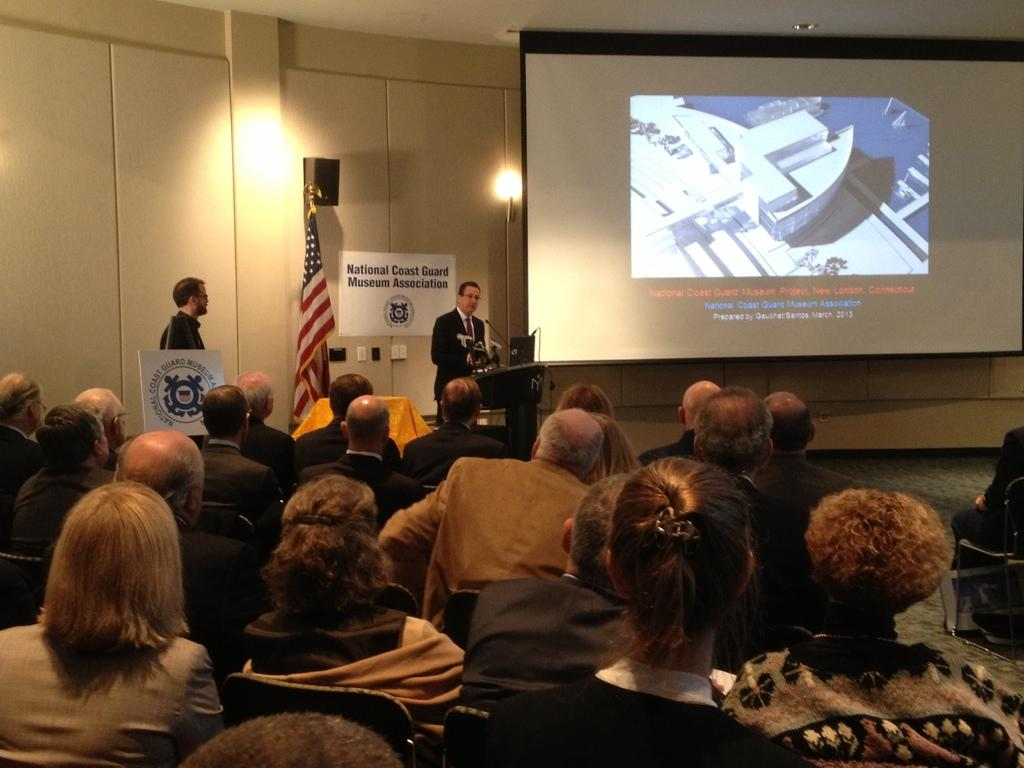What are the people in the image doing? The people in the image are sitting on chairs. What object is present in the image that might be used for speaking or presenting? There is a podium in the image, which is often used for speaking or presenting. What device is present in the image that might be used for amplifying sound? There is a microphone in the image, which is used for amplifying sound. What symbol or emblem is present in the image? There is a flag in the image, which often represents a symbol or emblem. What object is present in the image that might be used for displaying information or visuals? There is a screen in the image, which is often used for displaying information or visuals. What objects are present in the image that might be used for illumination? There are lights in the image, which are used for illumination. How many stitches are visible on the flag in the image? There is no mention of stitches or any specific details about the flag in the image, so it is not possible to determine the number of stitches. 